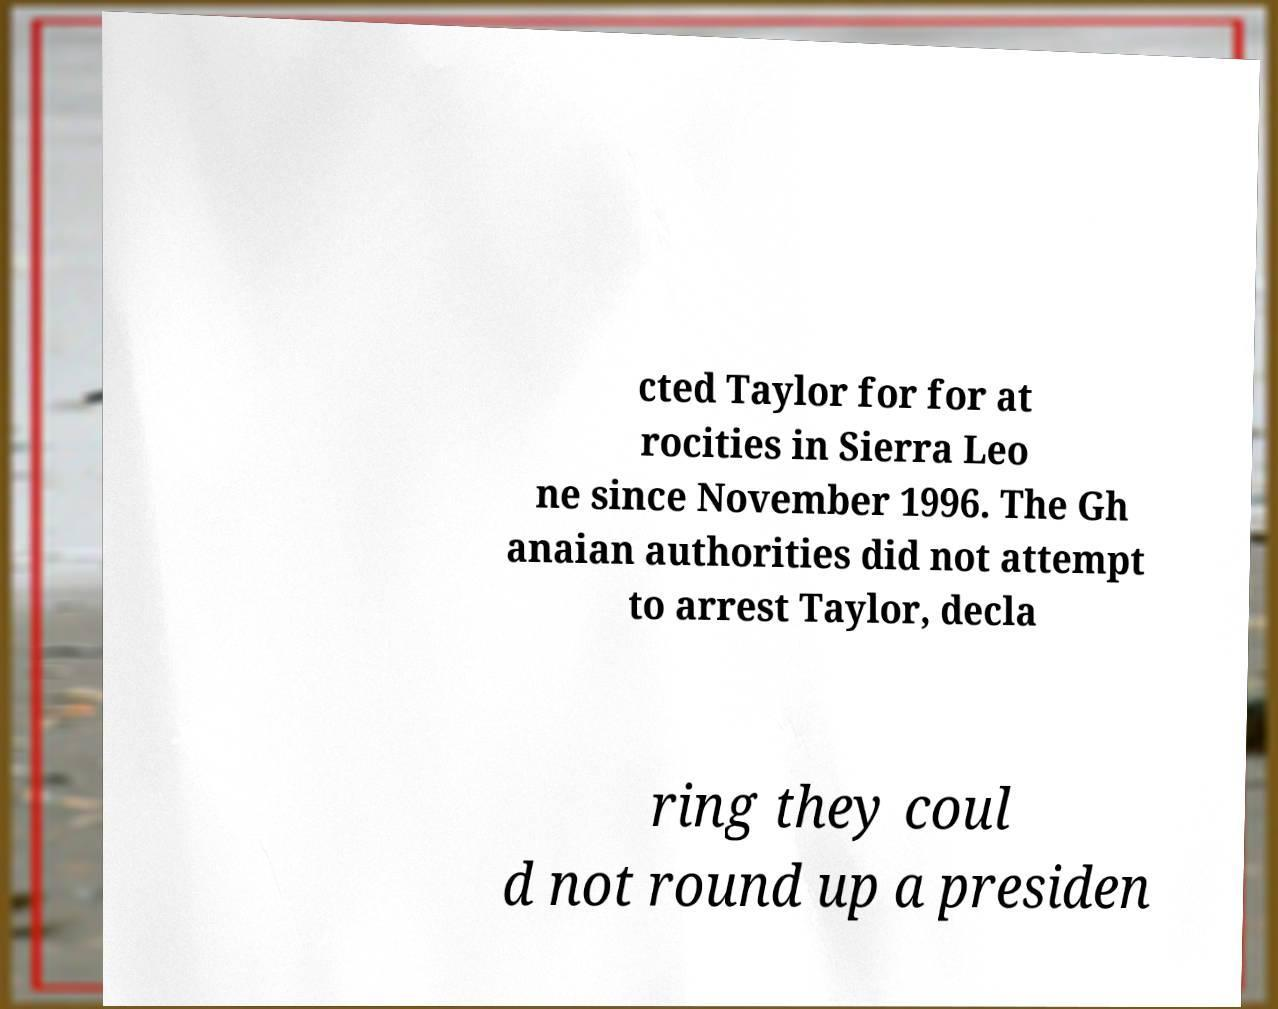Please read and relay the text visible in this image. What does it say? cted Taylor for for at rocities in Sierra Leo ne since November 1996. The Gh anaian authorities did not attempt to arrest Taylor, decla ring they coul d not round up a presiden 